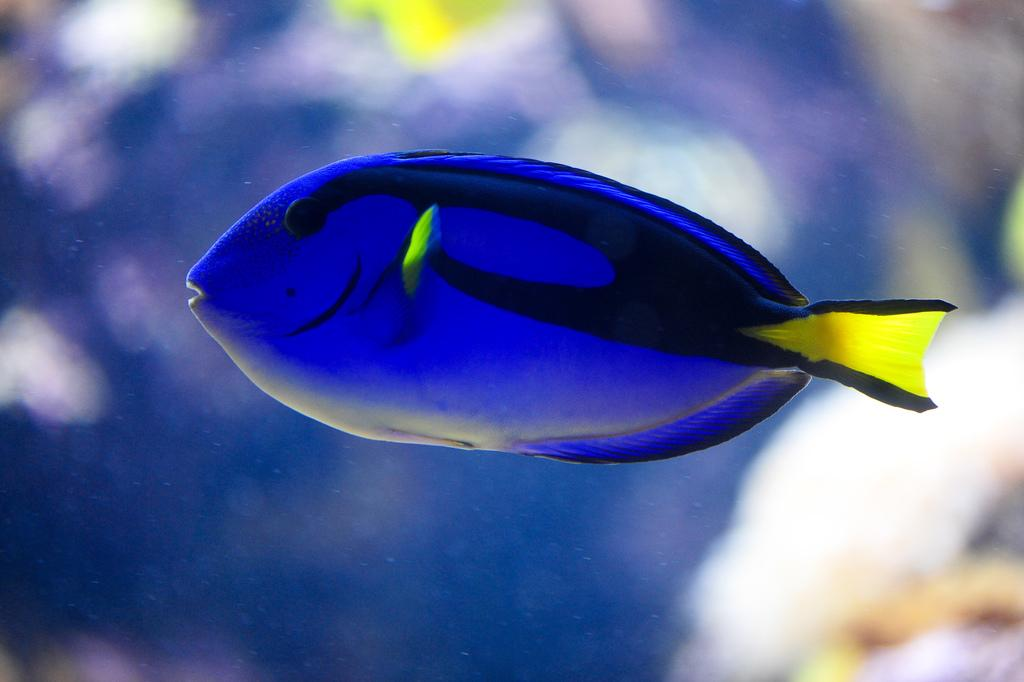What type of animal is in the image? There is a fish in the image. Where is the fish located? The fish is in the water. What type of brass instrument is being played by the fish in the image? There is no brass instrument or any indication of music in the image; it simply features a fish in the water. 